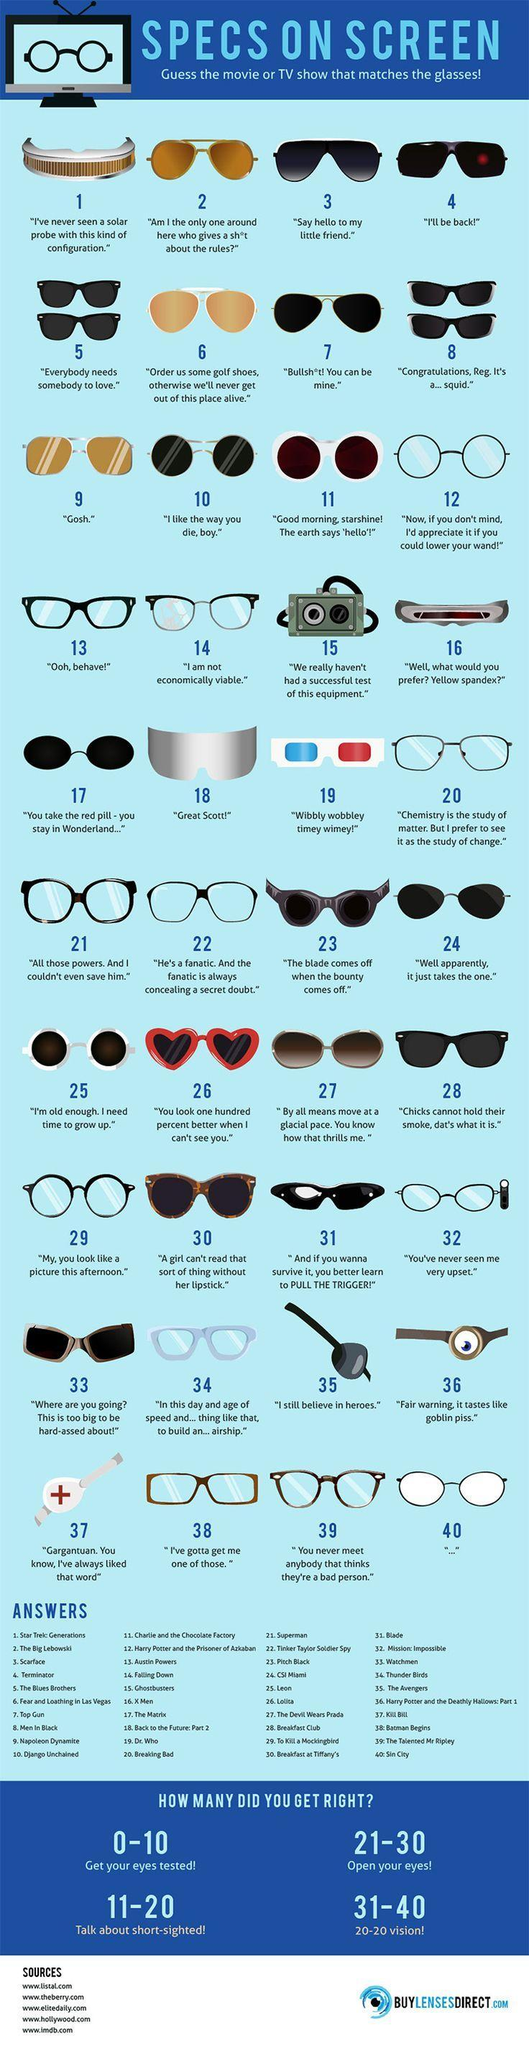Which is the glass that suits for "I still believe in heroes"?
Answer the question with a short phrase. The Avengers Which is the glass that suits for "---"? Sin City Which is the glass that suits for "I'll be back!"? Terminator Which is the glass that suits for "Gosh"? Napoleon Dynamite Which is the glass that suits for "Great Scott!"? Back to the future: Part 2 